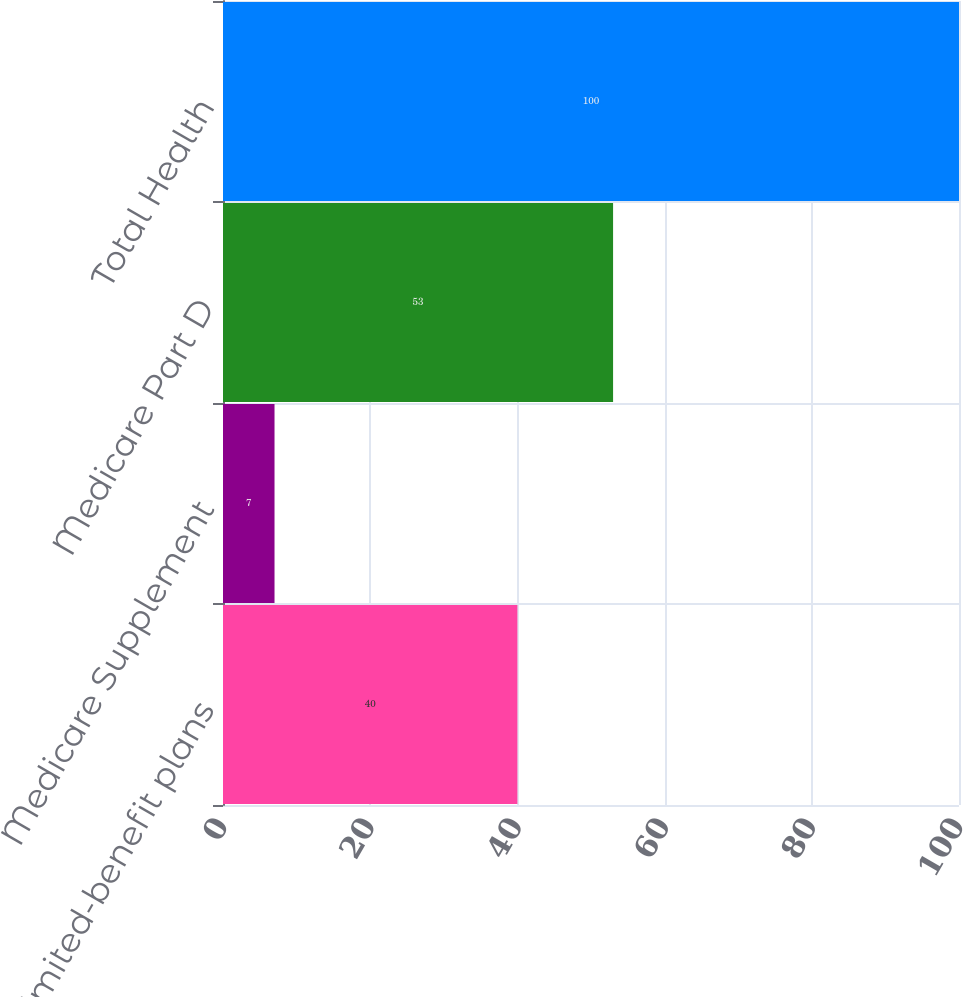Convert chart. <chart><loc_0><loc_0><loc_500><loc_500><bar_chart><fcel>Limited-benefit plans<fcel>Medicare Supplement<fcel>Medicare Part D<fcel>Total Health<nl><fcel>40<fcel>7<fcel>53<fcel>100<nl></chart> 